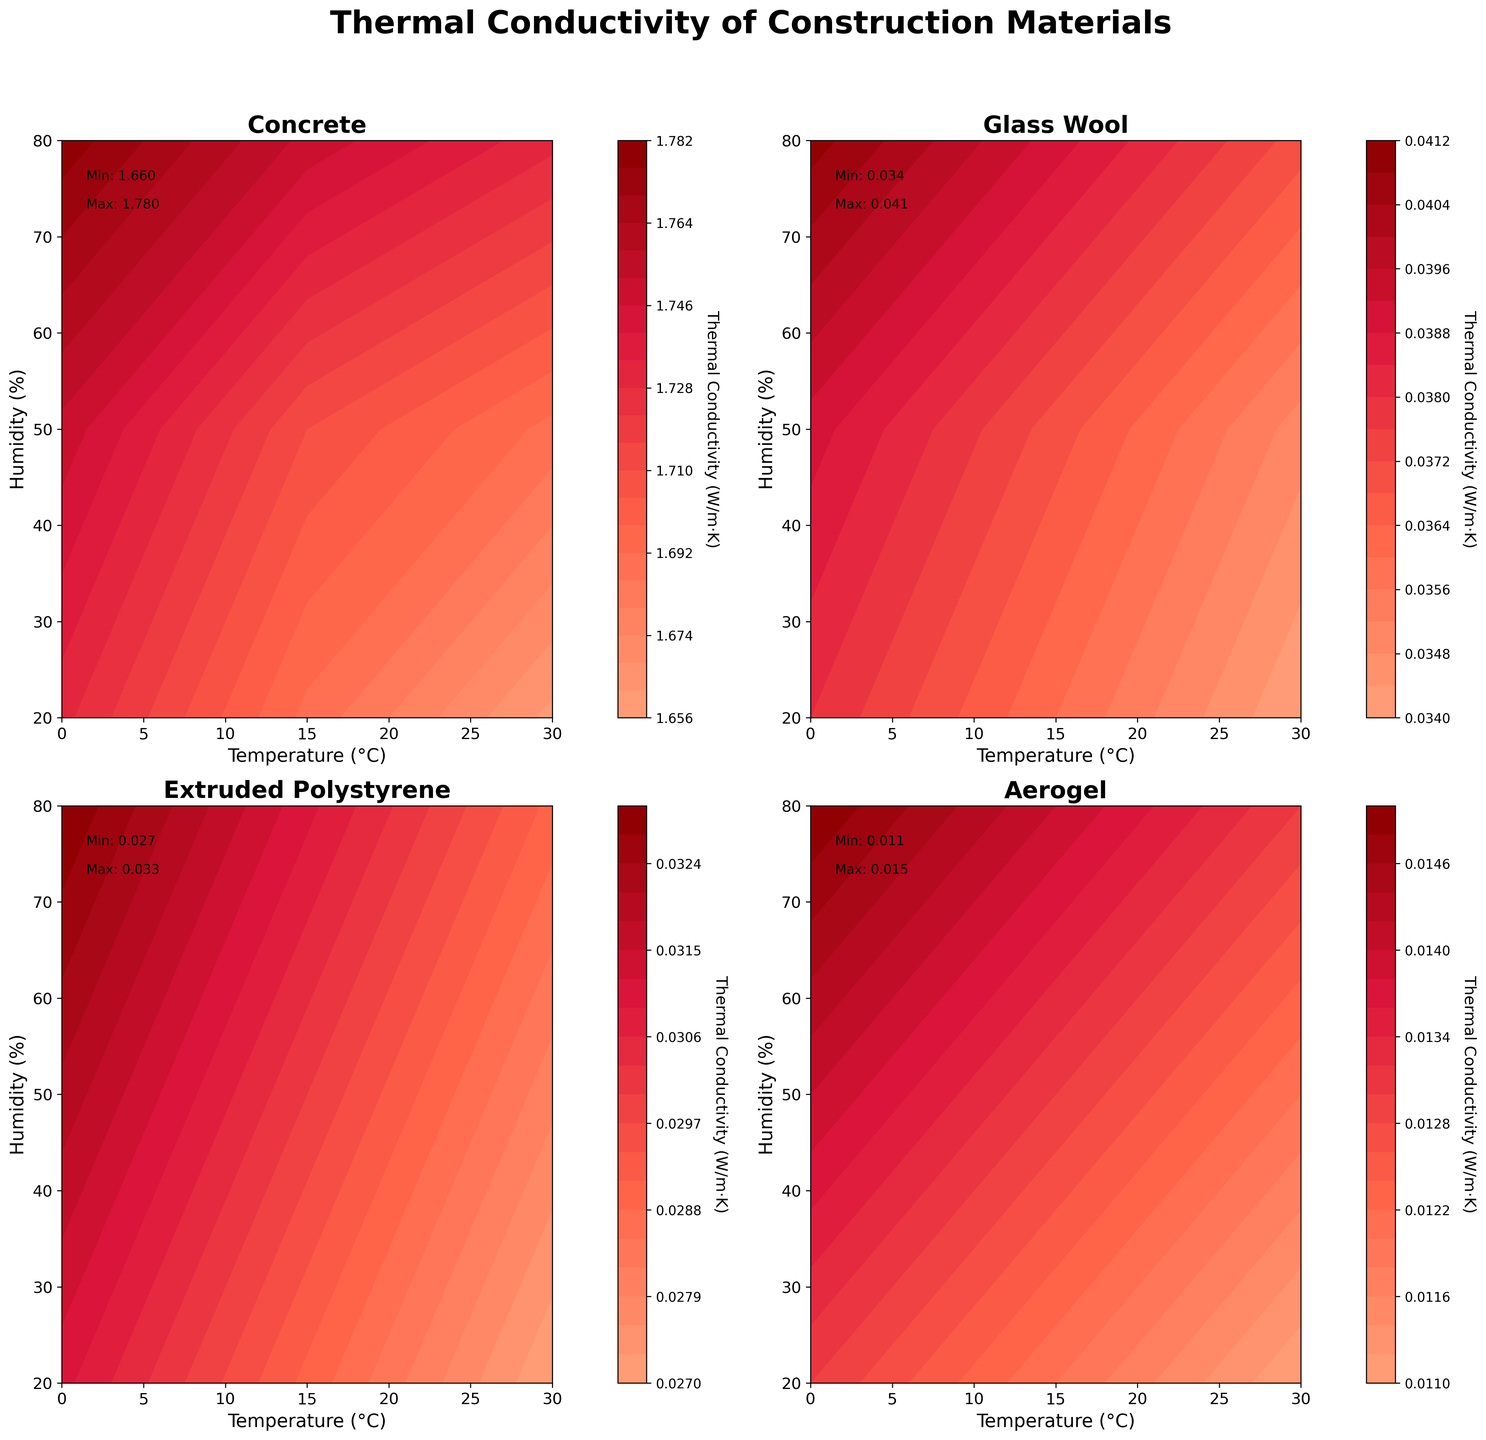What is the title of the figure? The title of the figure is located at the top center of the plotting area and is typically presented in a larger and bolder font compared to other text. In this case, the title says 'Thermal Conductivity of Construction Materials'.
Answer: Thermal Conductivity of Construction Materials What material shows the lowest thermal conductivity? From looking at each subplot, we can see that Aerogel consistently has the lowest thermal conductivity values. The minimum conductivity value for Aerogel is 0.011 W/m·K, which is the lowest among all the materials shown.
Answer: Aerogel Between Concrete and Glass Wool, which material has higher thermal conductivity? By comparing the subplots for Concrete and Glass Wool, we see that Concrete has higher thermal conductivity values. For instance, Concrete ranges approximately from 1.66 to 1.78 W/m·K, while Glass Wool ranges roughly from 0.034 to 0.041 W/m·K.
Answer: Concrete Describe the color range used for thermal conductivity in the contour plots. The color range goes from light salmon (#FFA07A) representing lower thermal conductivities to dark red (#8B0000) representing higher thermal conductivities. These colors help to easily distinguish different levels of thermal conductivity across the plots.
Answer: Light salmon to dark red What is the thermal conductivity of Extruded Polystyrene at the highest temperature and humidity? To find this, locate the point corresponding to a temperature of 30°C and a humidity of 80% on Extruded Polystyrene's plot. The thermal conductivity value at this point is annotated as 0.029 W/m·K.
Answer: 0.029 W/m·K Which material has the smallest range of thermal conductivity values? By examining the min and max thermal conductivity values (annotated in each subplot), Aerogel has the range of 0.002 W/m·K (from 0.011 to 0.013 W/m·K), which is the smallest range among the four materials shown.
Answer: Aerogel For which temperature does Concrete show the lowest thermal conductivity? By inspecting the contour lines, we can see that Concrete’s lowest thermal conductivity is at the highest temperature tested (30°C) with a value of approximately 1.66 W/m·K.
Answer: 30°C How does the thermal conductivity of Glass Wool change with increasing temperature at a constant humidity of 50%? In the Glass Wool subplot, trace the contour values at 50% humidity. The thermal conductivity decreases from 0.039 W/m·K at 0°C, to 0.037 W/m·K at 15°C, and further decreases to 0.035 W/m·K at 30°C, indicating a decreasing trend.
Answer: It decreases Explain the relationship between humidity and thermal conductivity for Aerogel displayed in the plot. By observing the Aerogel subplot, as humidity increases (keeping temperature constant), the thermal conductivity shows a slight increase. For example, at 30°C, it increases from 0.011 W/m·K at 20% humidity to 0.013 W/m·K at 80% humidity.
Answer: Thermal conductivity slightly increases with humidity What is the maximum thermal conductivity value for Concrete, and where does it occur? By viewing Concrete’s subplot, we can find the maximum thermal conductivity value is 1.78 W/m·K. This occurs at 0°C temperature and 80% humidity, as annotated in the subplot text.
Answer: 1.78 W/m·K at 0°C, 80% humidity 